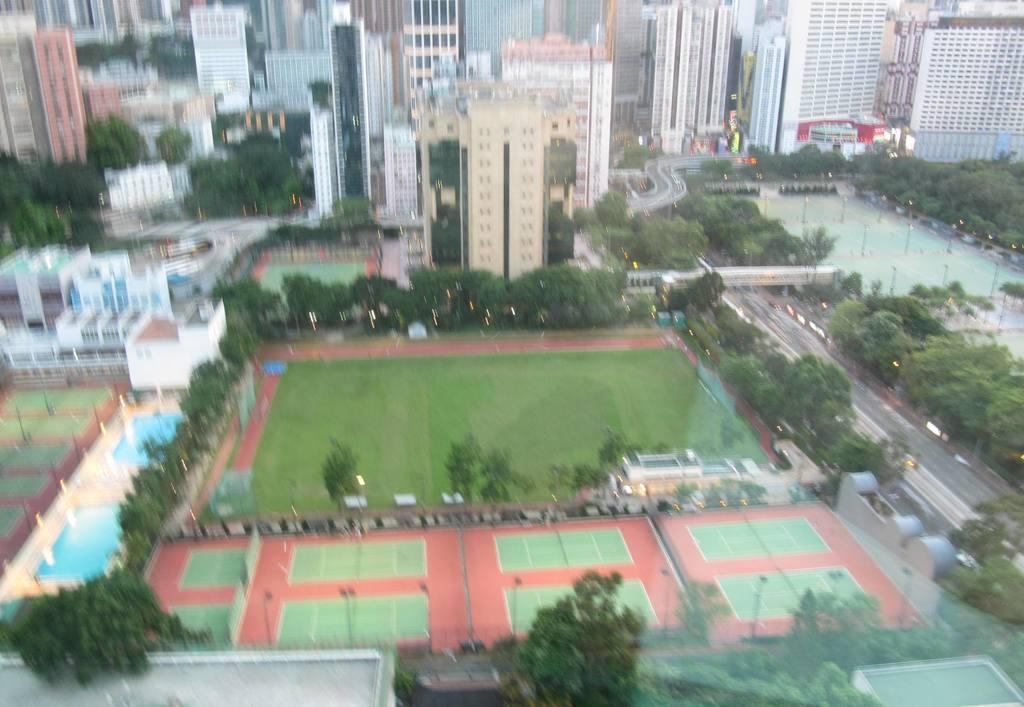What type of vegetation can be seen in the image? There are trees in the image. What type of structures are present in the image? There are poles and buildings in the image. How many frogs can be seen sitting on the buildings in the image? There are no frogs present in the image; it features trees, poles, and buildings. What type of pollution can be seen in the image? There is no pollution visible in the image. Can you tell me how many horses are tied to the poles in the image? There are no horses present in the image. 